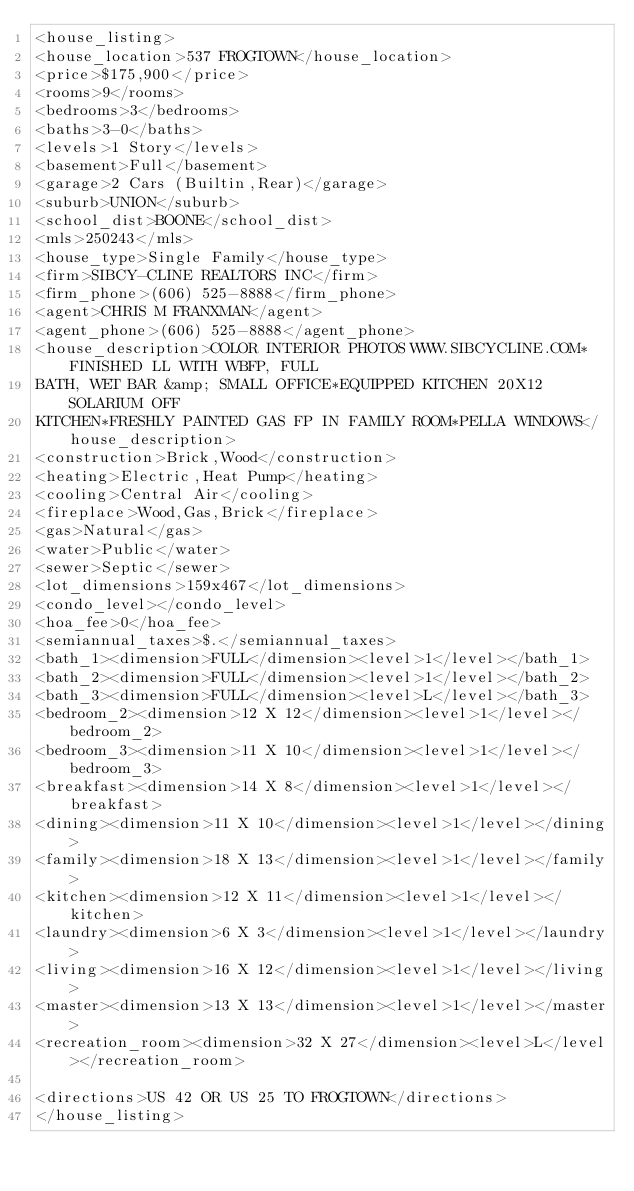<code> <loc_0><loc_0><loc_500><loc_500><_XML_><house_listing>
<house_location>537 FROGTOWN</house_location>
<price>$175,900</price>
<rooms>9</rooms>
<bedrooms>3</bedrooms>
<baths>3-0</baths>
<levels>1 Story</levels>
<basement>Full</basement>
<garage>2 Cars (Builtin,Rear)</garage>
<suburb>UNION</suburb>
<school_dist>BOONE</school_dist>
<mls>250243</mls>
<house_type>Single Family</house_type>
<firm>SIBCY-CLINE REALTORS INC</firm>
<firm_phone>(606) 525-8888</firm_phone>
<agent>CHRIS M FRANXMAN</agent>
<agent_phone>(606) 525-8888</agent_phone>
<house_description>COLOR INTERIOR PHOTOS WWW.SIBCYCLINE.COM*FINISHED LL WITH WBFP, FULL
BATH, WET BAR &amp; SMALL OFFICE*EQUIPPED KITCHEN 20X12 SOLARIUM OFF
KITCHEN*FRESHLY PAINTED GAS FP IN FAMILY ROOM*PELLA WINDOWS</house_description>
<construction>Brick,Wood</construction>
<heating>Electric,Heat Pump</heating>
<cooling>Central Air</cooling>
<fireplace>Wood,Gas,Brick</fireplace>
<gas>Natural</gas>
<water>Public</water>
<sewer>Septic</sewer>
<lot_dimensions>159x467</lot_dimensions>
<condo_level></condo_level>
<hoa_fee>0</hoa_fee>
<semiannual_taxes>$.</semiannual_taxes>
<bath_1><dimension>FULL</dimension><level>1</level></bath_1>
<bath_2><dimension>FULL</dimension><level>1</level></bath_2>
<bath_3><dimension>FULL</dimension><level>L</level></bath_3>
<bedroom_2><dimension>12 X 12</dimension><level>1</level></bedroom_2>
<bedroom_3><dimension>11 X 10</dimension><level>1</level></bedroom_3>
<breakfast><dimension>14 X 8</dimension><level>1</level></breakfast>
<dining><dimension>11 X 10</dimension><level>1</level></dining>
<family><dimension>18 X 13</dimension><level>1</level></family>
<kitchen><dimension>12 X 11</dimension><level>1</level></kitchen>
<laundry><dimension>6 X 3</dimension><level>1</level></laundry>
<living><dimension>16 X 12</dimension><level>1</level></living>
<master><dimension>13 X 13</dimension><level>1</level></master>
<recreation_room><dimension>32 X 27</dimension><level>L</level></recreation_room>

<directions>US 42 OR US 25 TO FROGTOWN</directions>
</house_listing>



</code> 